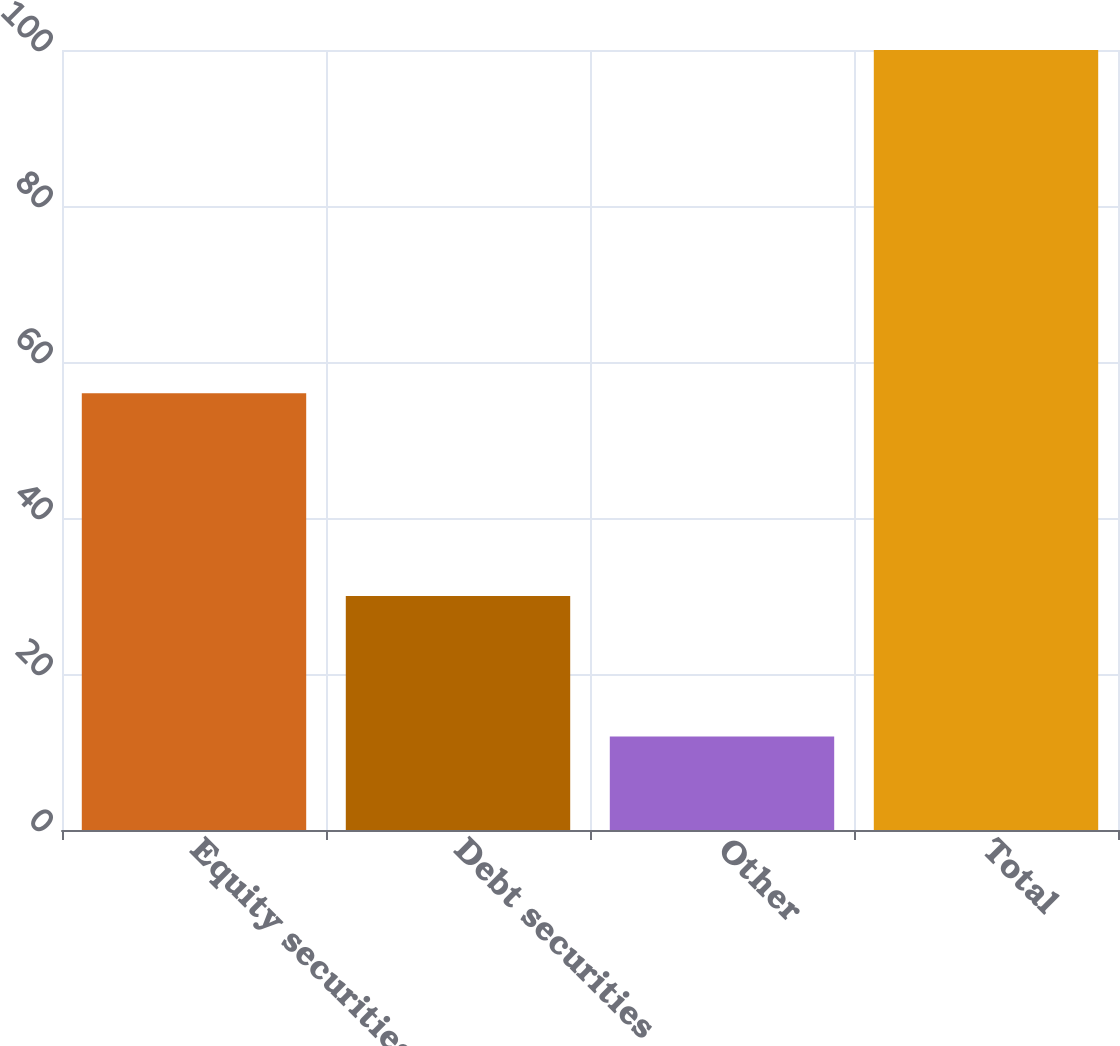<chart> <loc_0><loc_0><loc_500><loc_500><bar_chart><fcel>Equity securities<fcel>Debt securities<fcel>Other<fcel>Total<nl><fcel>56<fcel>30<fcel>12<fcel>100<nl></chart> 